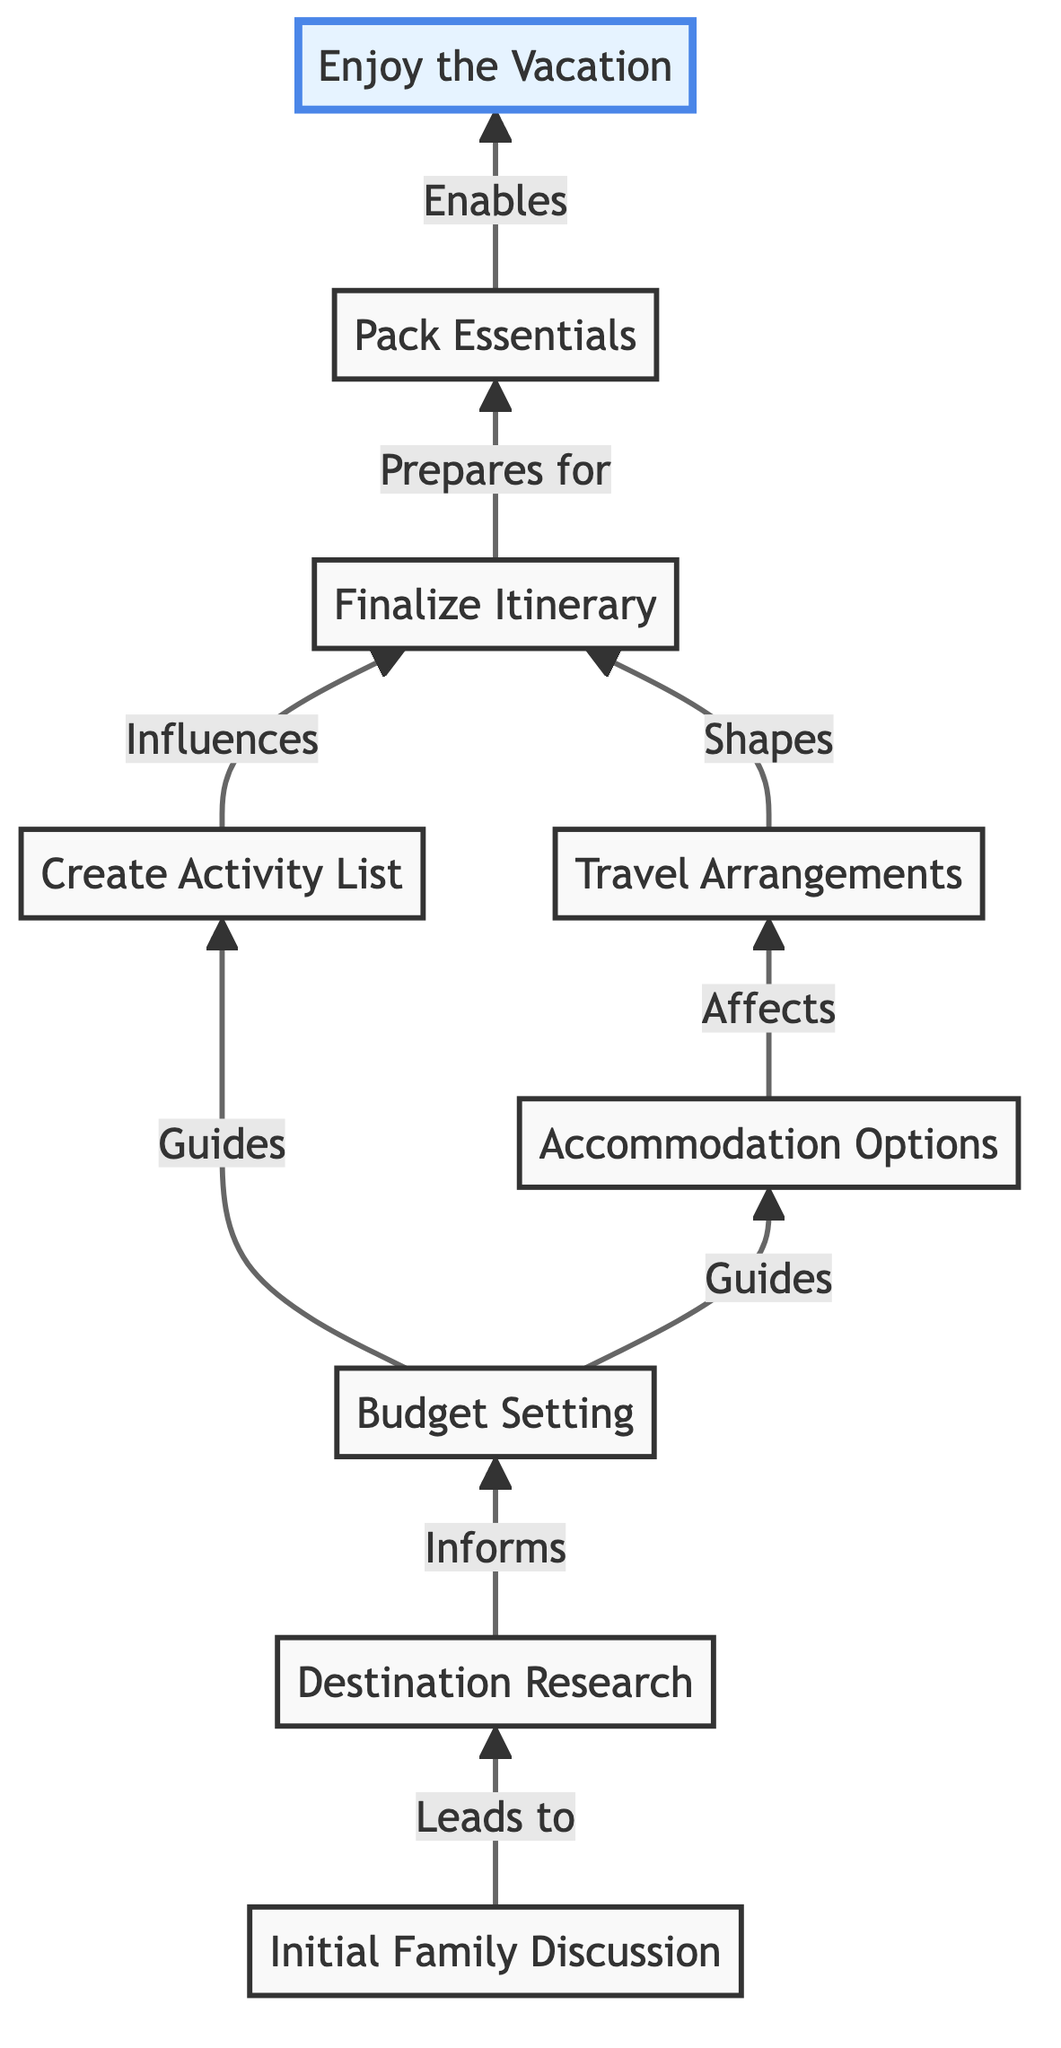What is the first step in the vacation planning process? The first step is "Initial Family Discussion," which indicates the gathering of family members to discuss vacation ideas and preferences.
Answer: Initial Family Discussion Which two steps does "Budget Setting" guide? "Budget Setting" guides the next steps "Create Activity List" and "Accommodation Options." By analyzing the budget, families can determine what activities to include and what types of accommodations are feasible.
Answer: Create Activity List and Accommodation Options How many total nodes are present in the diagram? The diagram contains ten nodes representing various stages of the vacation planning process, including the activities and final vacation enjoyment.
Answer: Ten What affects the step "Travel Arrangements"? The step "Accommodation Options" affects "Travel Arrangements." Once accommodations are decided, families can then arrange for the appropriate travel logistics to get to and from their destination.
Answer: Accommodation Options What step directly precedes "Pack Essentials"? The step that directly precedes "Pack Essentials" is "Finalize Itinerary." This step involves creating a daily plan, which informs what items need to be packed for the trip.
Answer: Finalize Itinerary Which step is described as "enables" the final outcome of the vacation experience? The step described as "enables" the outcome is "Pack Essentials." By preparing the necessary items, families ensure they are ready for the activities planned during the vacation.
Answer: Pack Essentials What is the last activity listed in the flow? The last activity listed in the flow is "Enjoy the Vacation," indicating that after completing all the planning and preparations, the family embarks on their vacation.
Answer: Enjoy the Vacation What is the relationship between "Create Activity List" and "Budget Setting"? "Create Activity List" is influenced by "Budget Setting." The available budget will guide which activities can realistically be included in the vacation plans.
Answer: Influences What type of diagram is represented by this flow? This diagram represents a Bottom Up Flow Chart, showcasing the sequential steps involved in planning and booking a family vacation.
Answer: Bottom Up Flow Chart 